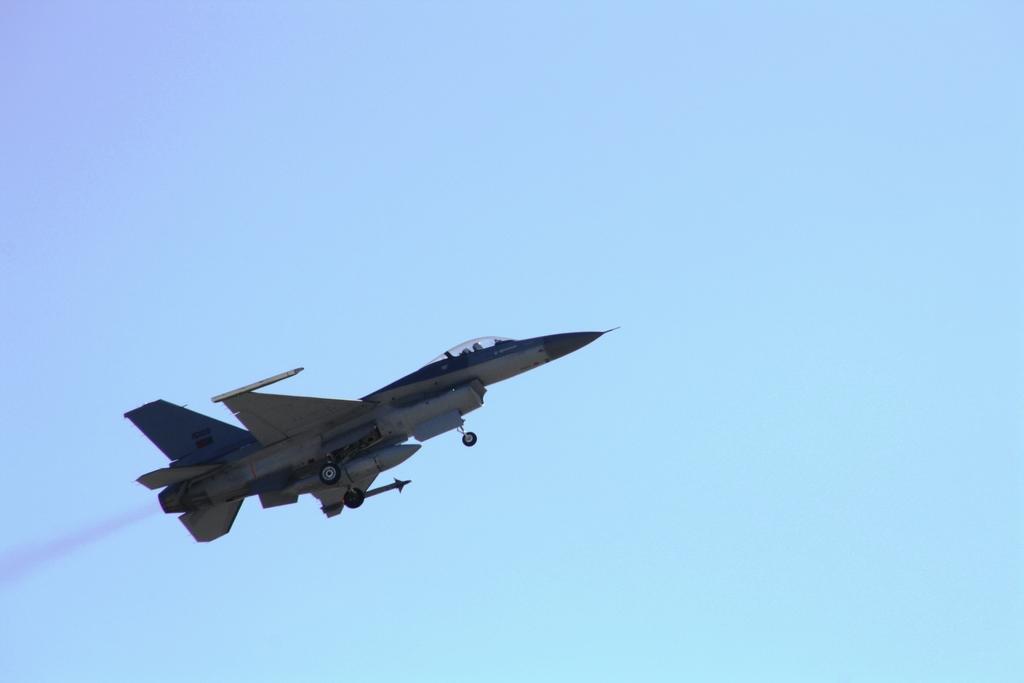Please provide a concise description of this image. In this image I can see an aircraft in air. Here I can see smoke and I can also see blue colour in the background. 